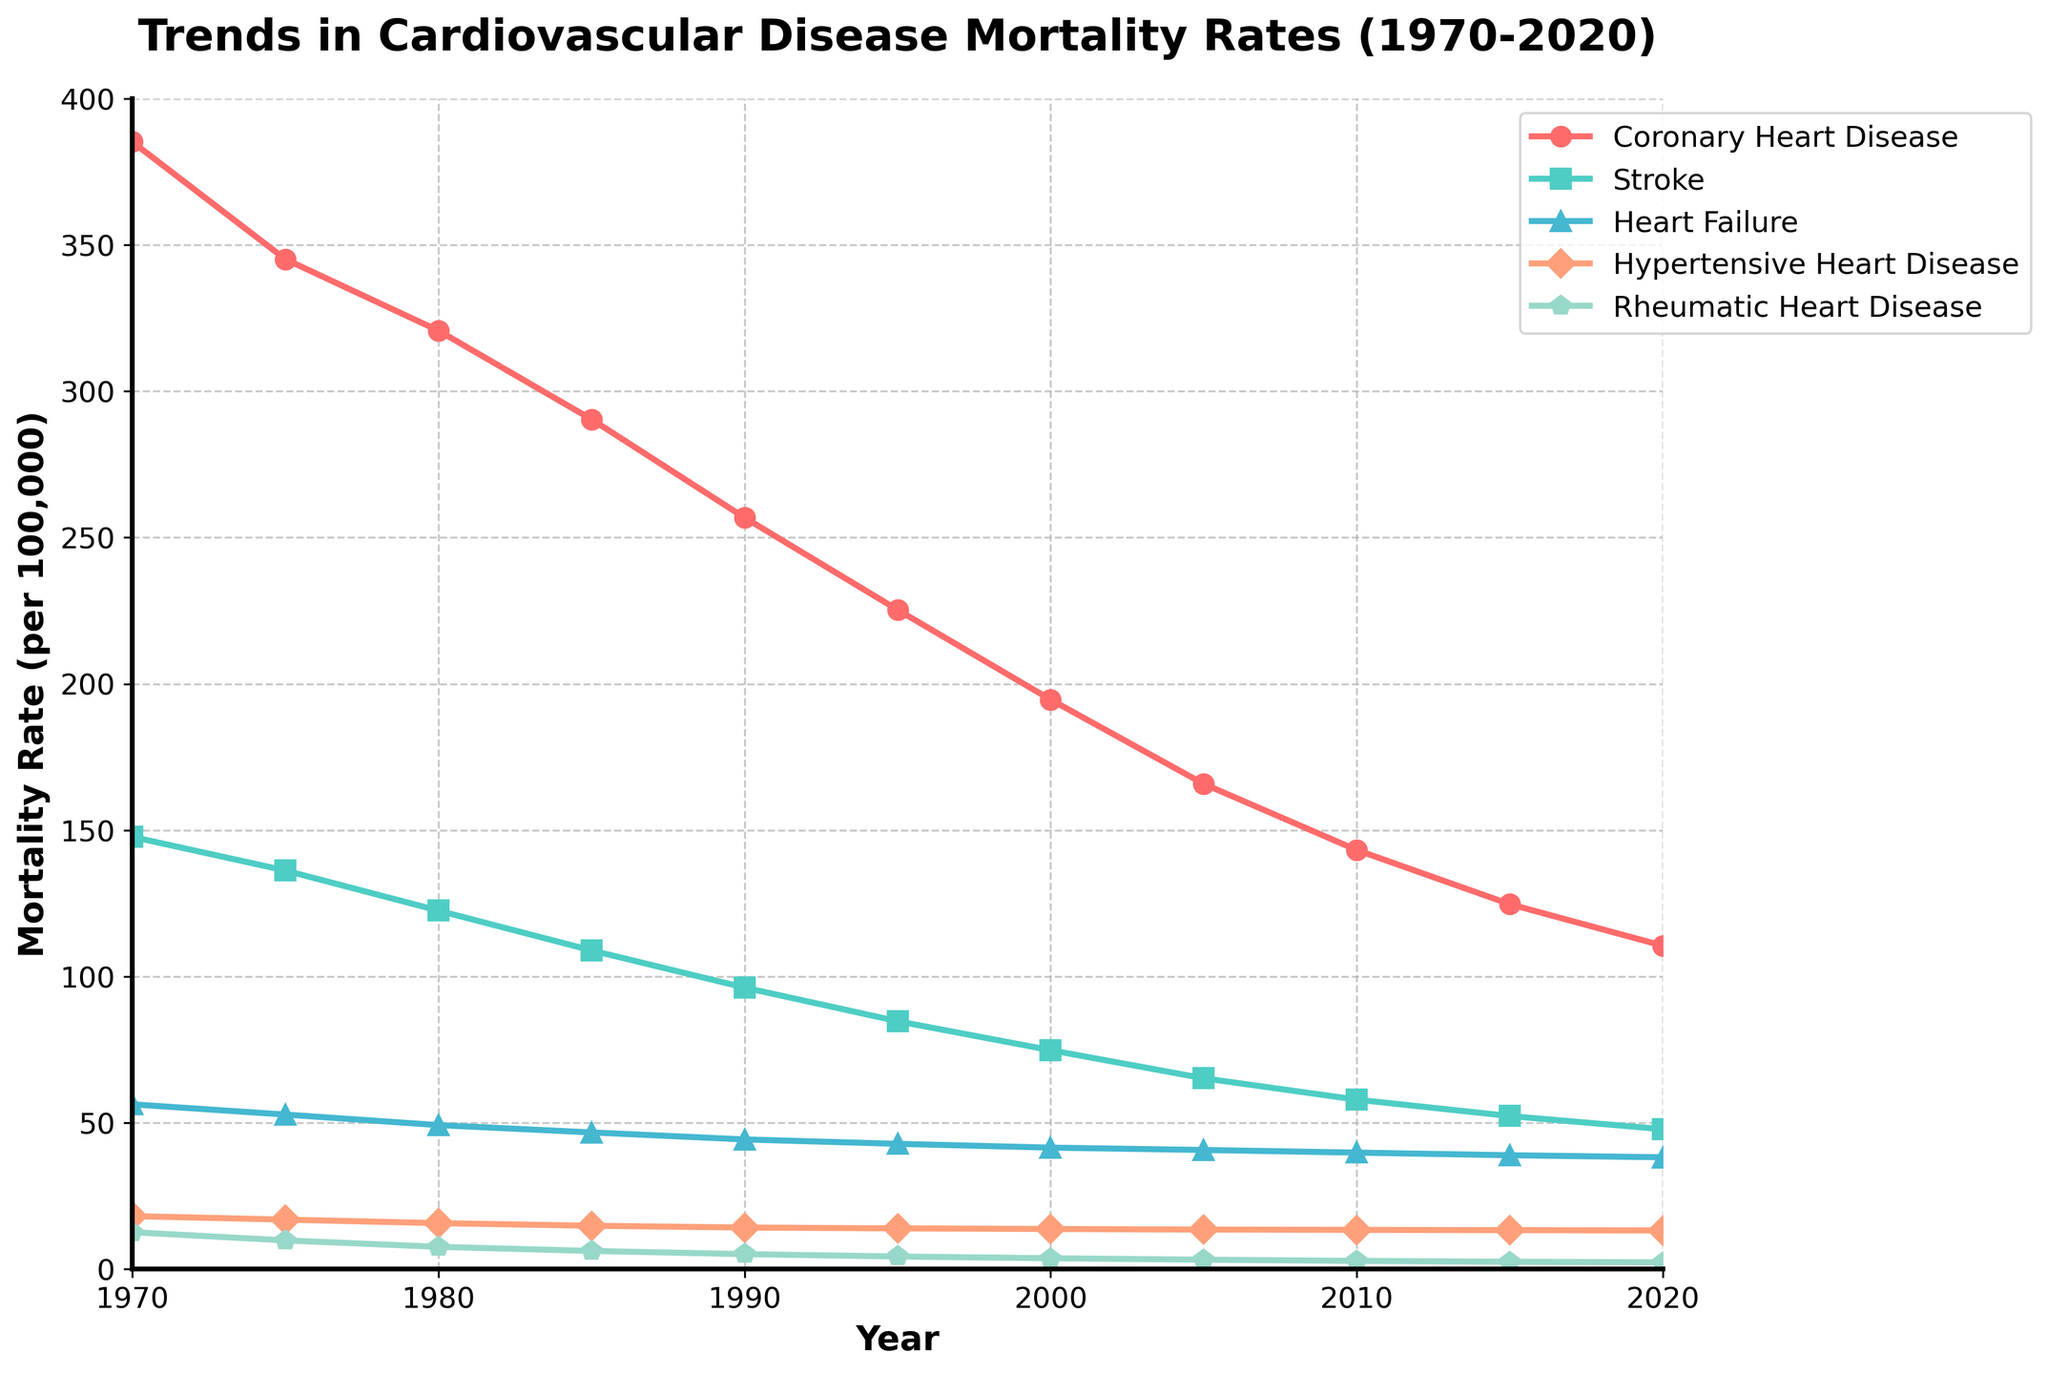What is the overall trend in mortality rates for Coronary Heart Disease from 1970 to 2020? The line for Coronary Heart Disease is consistently decreasing over the years, starting at 385.2 in 1970 and ending at 110.5 in 2020, indicating a downward trend.
Answer: Downward trend Which heart condition had the smallest reduction in mortality rates between 1970 and 2020? By comparing the starting and ending points of each line, Rheumatic Heart Disease had the smallest reduction, decreasing from 12.6 in 1970 to 2.3 in 2020, a difference of 10.3.
Answer: Rheumatic Heart Disease Between what years did Stroke mortality rates see the most significant drop? By looking at the slope of the line for Stroke, the steepest decline appears between 1970 and 1980. The rate drops from 147.7 to 122.5, a difference of 25.2.
Answer: 1970 and 1980 How do the mortality rates for Heart Failure in 1990 compare to those for Hypertensive Heart Disease in 2020? From the graph, Heart Failure in 1990 is at 44.3, and Hypertensive Heart Disease in 2020 is at 13.2. Therefore, Heart Failure in 1990 is significantly higher.
Answer: Higher Which condition had the highest mortality rate in 1980? From the graph, the line for Coronary Heart Disease is highest among all conditions in 1980, with a rate of 320.7.
Answer: Coronary Heart Disease What is the difference in mortality rates between Coronary Heart Disease and Heart Failure in 2000? The graph shows that in 2000, Coronary Heart Disease had a rate of 194.6 and Heart Failure had a rate of 41.5. The difference is 194.6 - 41.5 = 153.1.
Answer: 153.1 Which condition had the steepest decline in mortality rates from 1970 to 1985? By looking at the slopes of the lines from 1970 to 1985, Stroke had a steep decline, dropping from 147.7 to 108.9, a difference of 38.8.
Answer: Stroke How much did mortality rates for Hypertensive Heart Disease change from 2005 to 2015? The graph shows Hypertensive Heart Disease rates of 13.5 in 2005 and 13.3 in 2015. The change is 13.5 - 13.3 = 0.2.
Answer: 0.2 Which heart condition has the light blue marker, and how does its mortality rate trend over the 50 years? The Stroke condition has the light blue marker. Its trend is consistently downward from 147.7 in 1970 to 47.8 in 2020.
Answer: Stroke, downward trend In what year did the mortality rate for Rheumatic Heart Disease first fall below 10 per 100,000? The graph shows that Rheumatic Heart Disease falls below 10 per 100,000 between 1975 and 1980. In 1975, it was 9.8, which is the first instance below 10.
Answer: 1975 